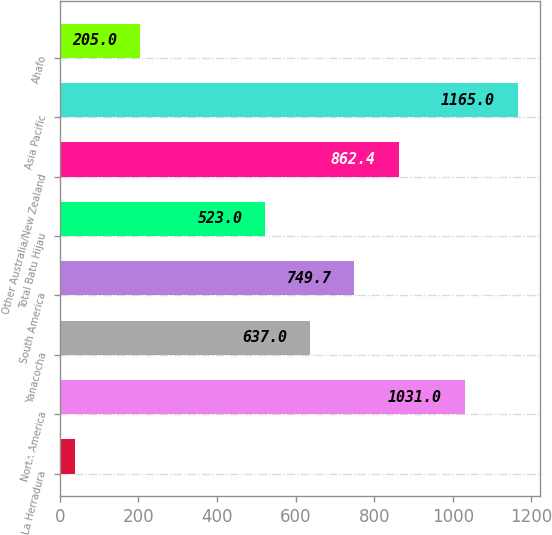<chart> <loc_0><loc_0><loc_500><loc_500><bar_chart><fcel>La Herradura<fcel>North America<fcel>Yanacocha<fcel>South America<fcel>Total Batu Hijau<fcel>Other Australia/New Zealand<fcel>Asia Pacific<fcel>Ahafo<nl><fcel>38<fcel>1031<fcel>637<fcel>749.7<fcel>523<fcel>862.4<fcel>1165<fcel>205<nl></chart> 